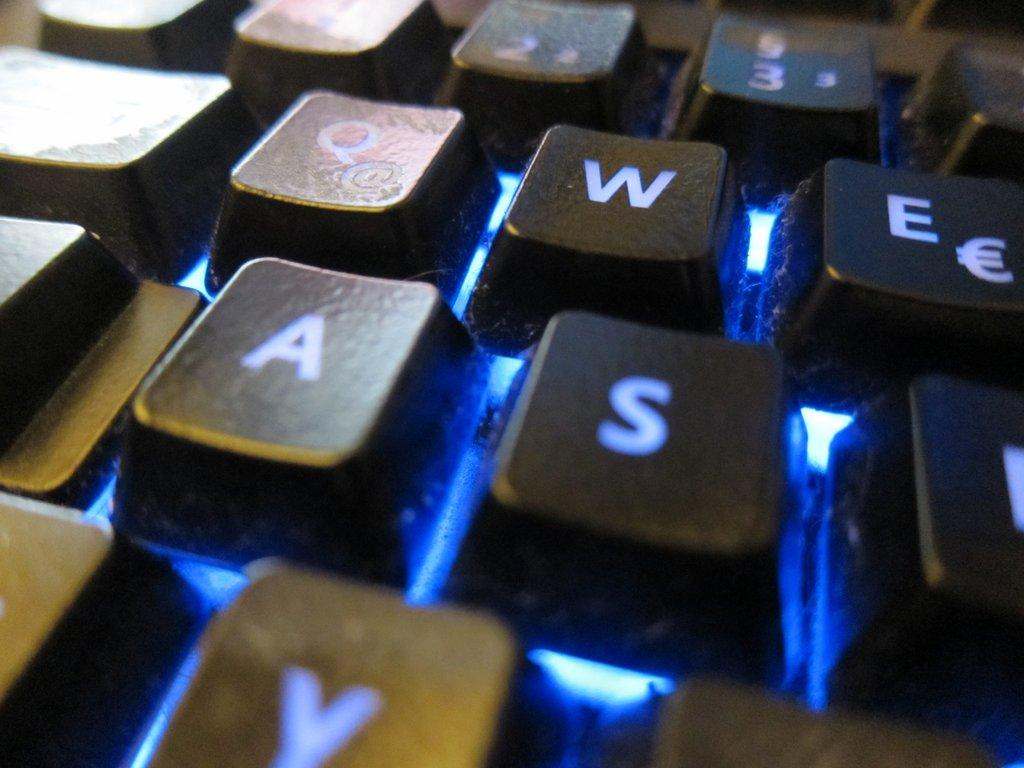Provide a one-sentence caption for the provided image. A keyboard with the letters W, E, A, S are visible. 